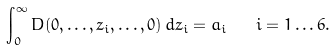Convert formula to latex. <formula><loc_0><loc_0><loc_500><loc_500>\int _ { 0 } ^ { \infty } D ( 0 , \dots , z _ { i } , \dots , 0 ) \, d z _ { i } = a _ { i } \quad i = 1 \dots 6 .</formula> 